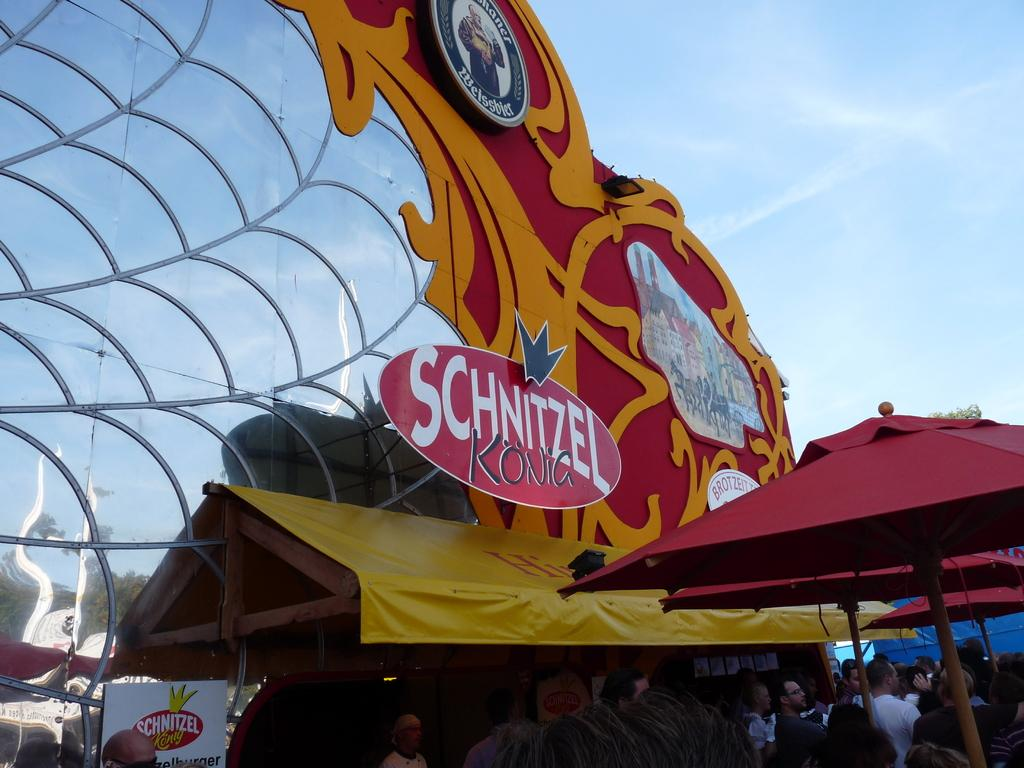<image>
Present a compact description of the photo's key features. A Fair is packed and a line of people are at the Schnitzel Kona. 